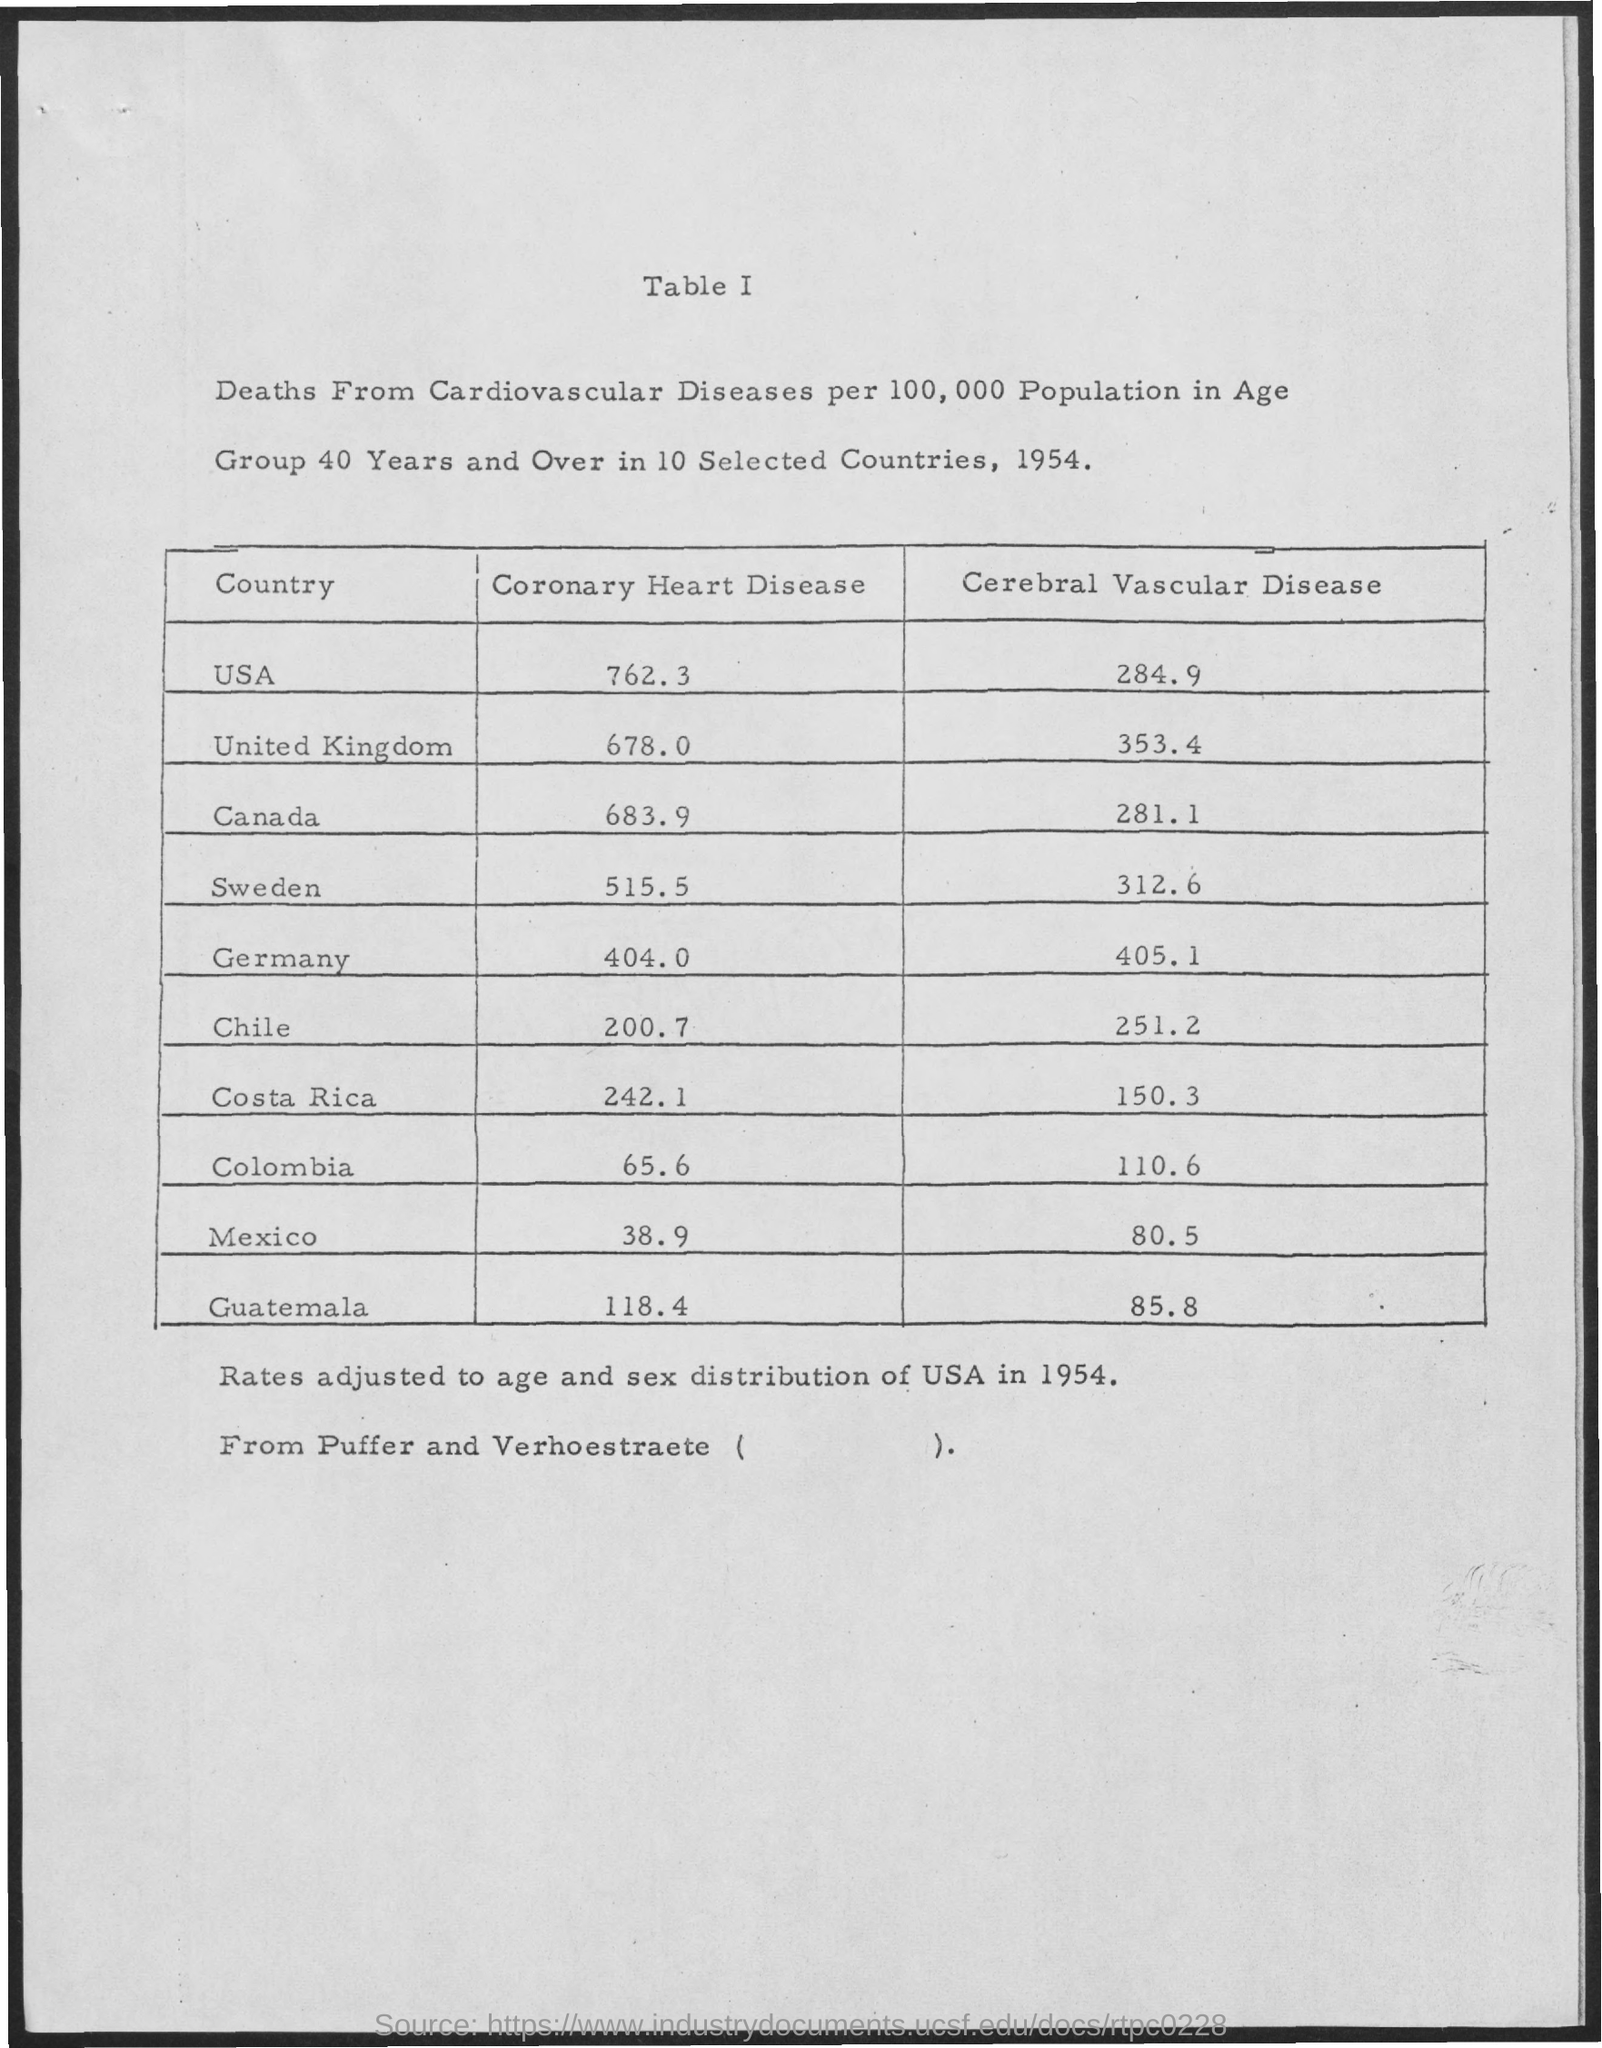What is written in the letter head ?
Provide a short and direct response. Table I. 